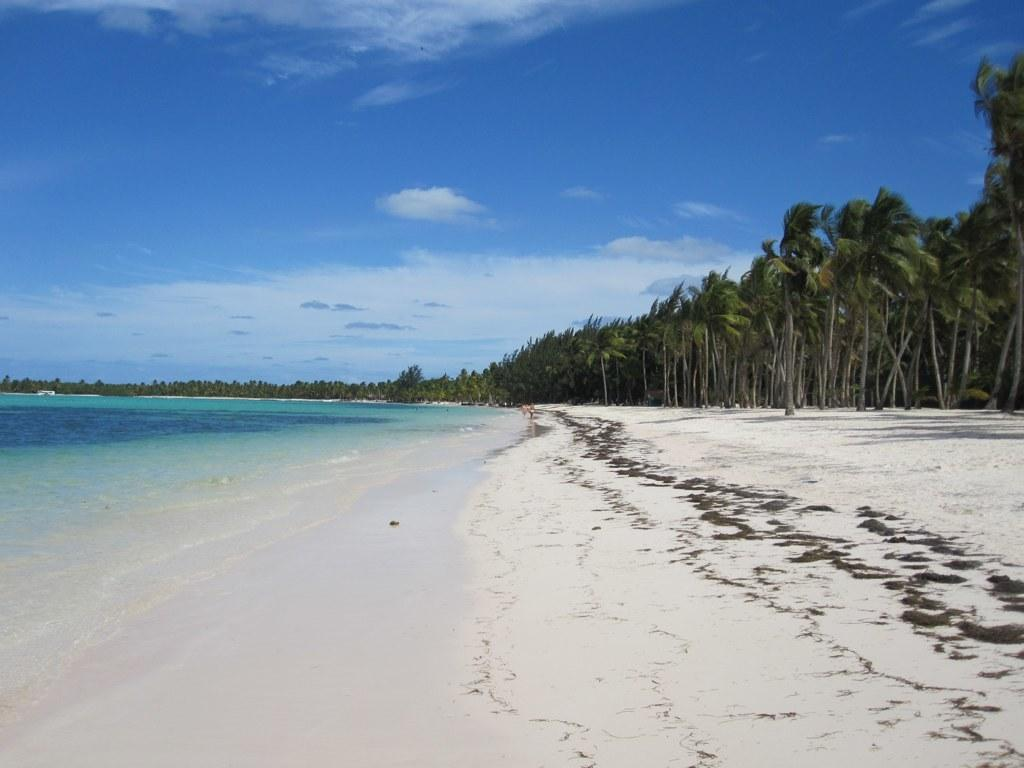What type of natural environment is depicted in the image? There is a sea shore in the image. What type of vegetation can be seen in the image? There are trees in the image. What is the condition of the sky in the image? The sky is clouded in the image. What type of cream is being served at the beach in the image? There is no cream or any food being served in the image; it depicts a sea shore with trees and a clouded sky. 